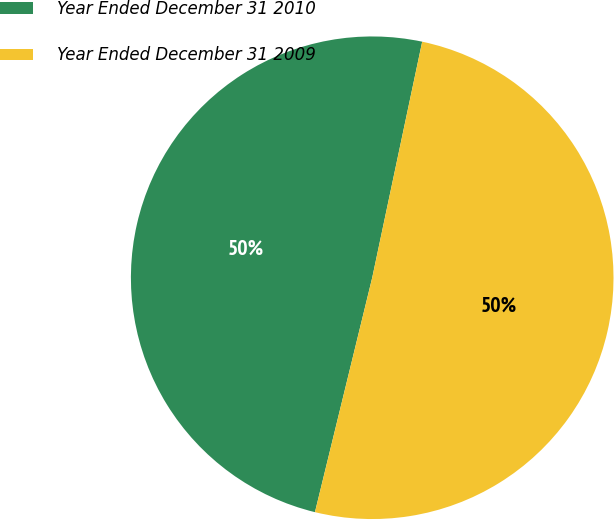Convert chart to OTSL. <chart><loc_0><loc_0><loc_500><loc_500><pie_chart><fcel>Year Ended December 31 2010<fcel>Year Ended December 31 2009<nl><fcel>49.51%<fcel>50.49%<nl></chart> 